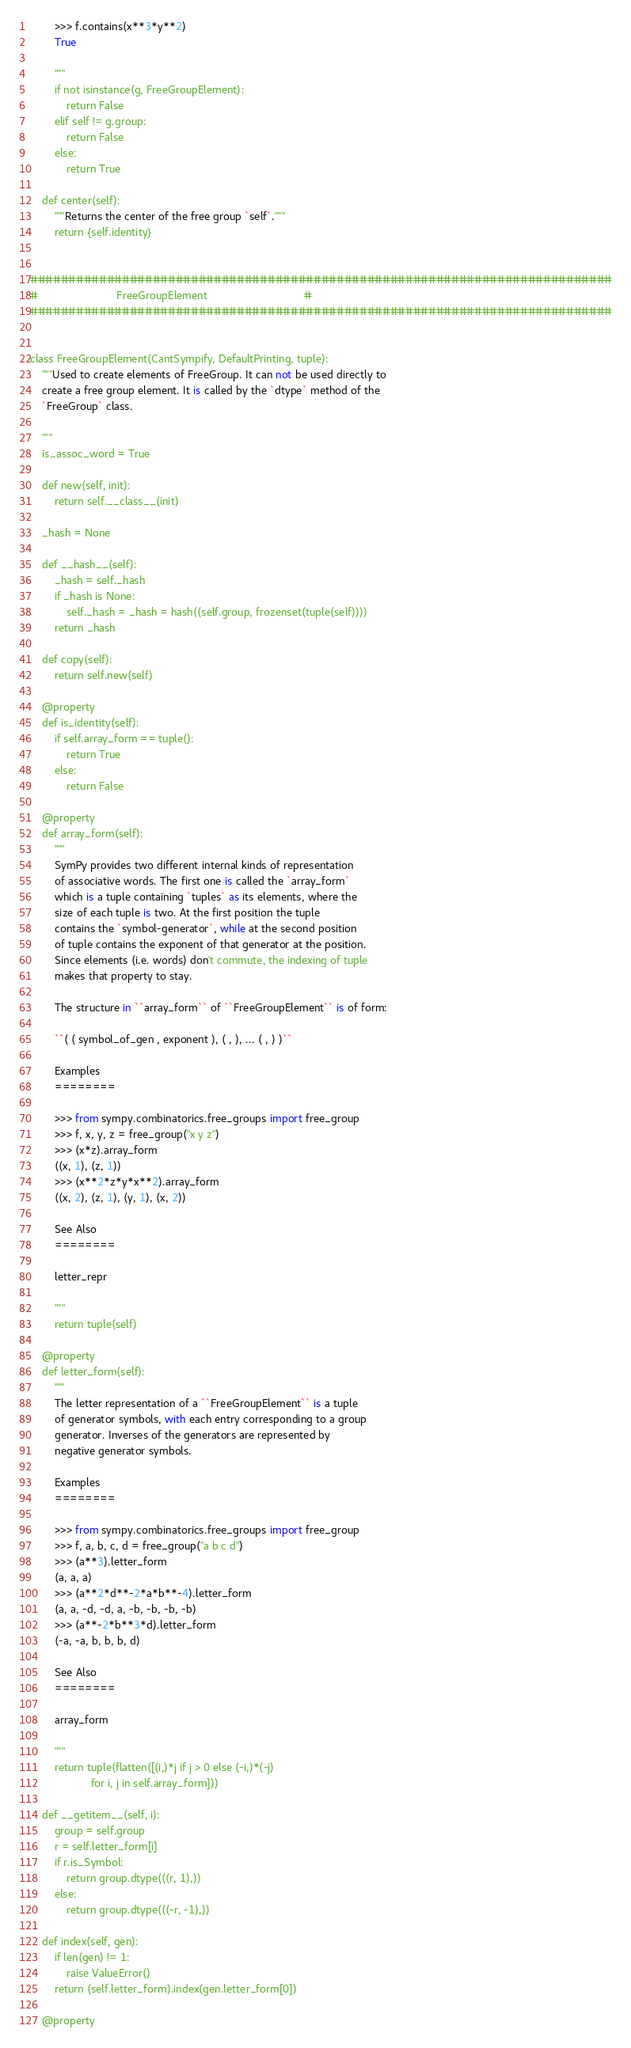<code> <loc_0><loc_0><loc_500><loc_500><_Python_>        >>> f.contains(x**3*y**2)
        True

        """
        if not isinstance(g, FreeGroupElement):
            return False
        elif self != g.group:
            return False
        else:
            return True

    def center(self):
        """Returns the center of the free group `self`."""
        return {self.identity}


############################################################################
#                          FreeGroupElement                                #
############################################################################


class FreeGroupElement(CantSympify, DefaultPrinting, tuple):
    """Used to create elements of FreeGroup. It can not be used directly to
    create a free group element. It is called by the `dtype` method of the
    `FreeGroup` class.

    """
    is_assoc_word = True

    def new(self, init):
        return self.__class__(init)

    _hash = None

    def __hash__(self):
        _hash = self._hash
        if _hash is None:
            self._hash = _hash = hash((self.group, frozenset(tuple(self))))
        return _hash

    def copy(self):
        return self.new(self)

    @property
    def is_identity(self):
        if self.array_form == tuple():
            return True
        else:
            return False

    @property
    def array_form(self):
        """
        SymPy provides two different internal kinds of representation
        of associative words. The first one is called the `array_form`
        which is a tuple containing `tuples` as its elements, where the
        size of each tuple is two. At the first position the tuple
        contains the `symbol-generator`, while at the second position
        of tuple contains the exponent of that generator at the position.
        Since elements (i.e. words) don't commute, the indexing of tuple
        makes that property to stay.

        The structure in ``array_form`` of ``FreeGroupElement`` is of form:

        ``( ( symbol_of_gen , exponent ), ( , ), ... ( , ) )``

        Examples
        ========

        >>> from sympy.combinatorics.free_groups import free_group
        >>> f, x, y, z = free_group("x y z")
        >>> (x*z).array_form
        ((x, 1), (z, 1))
        >>> (x**2*z*y*x**2).array_form
        ((x, 2), (z, 1), (y, 1), (x, 2))

        See Also
        ========

        letter_repr

        """
        return tuple(self)

    @property
    def letter_form(self):
        """
        The letter representation of a ``FreeGroupElement`` is a tuple
        of generator symbols, with each entry corresponding to a group
        generator. Inverses of the generators are represented by
        negative generator symbols.

        Examples
        ========

        >>> from sympy.combinatorics.free_groups import free_group
        >>> f, a, b, c, d = free_group("a b c d")
        >>> (a**3).letter_form
        (a, a, a)
        >>> (a**2*d**-2*a*b**-4).letter_form
        (a, a, -d, -d, a, -b, -b, -b, -b)
        >>> (a**-2*b**3*d).letter_form
        (-a, -a, b, b, b, d)

        See Also
        ========

        array_form

        """
        return tuple(flatten([(i,)*j if j > 0 else (-i,)*(-j)
                    for i, j in self.array_form]))

    def __getitem__(self, i):
        group = self.group
        r = self.letter_form[i]
        if r.is_Symbol:
            return group.dtype(((r, 1),))
        else:
            return group.dtype(((-r, -1),))

    def index(self, gen):
        if len(gen) != 1:
            raise ValueError()
        return (self.letter_form).index(gen.letter_form[0])

    @property</code> 